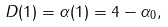Convert formula to latex. <formula><loc_0><loc_0><loc_500><loc_500>D ( 1 ) = \alpha ( 1 ) = 4 - \alpha _ { 0 } ,</formula> 